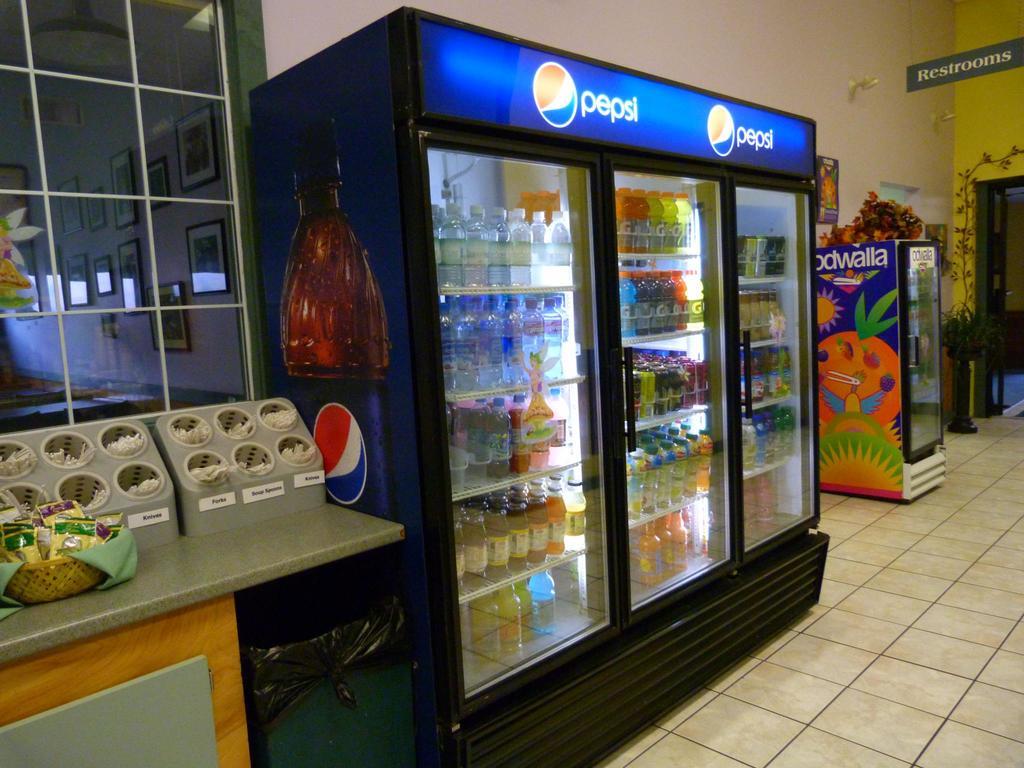What brand of soda is portrayed on the fridge?
Offer a terse response. Pepsi. What is the sign on the wall directing customers to?
Provide a short and direct response. Restrooms. 